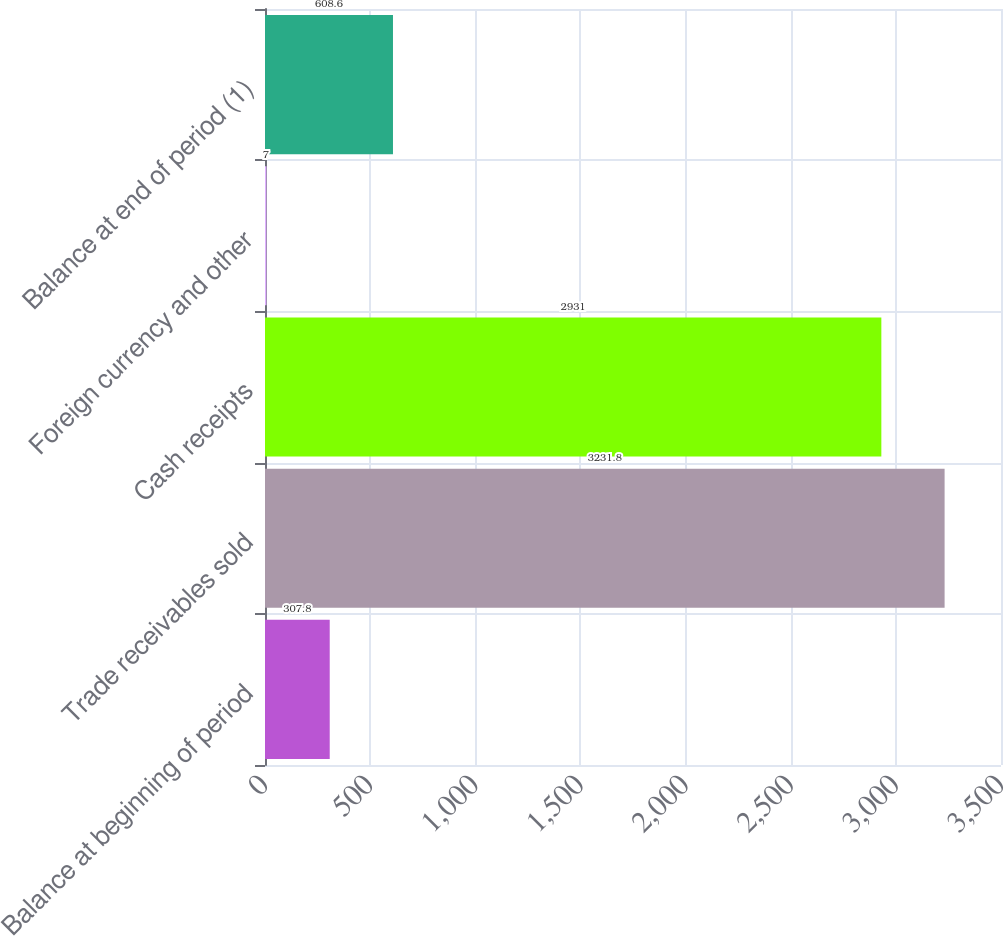<chart> <loc_0><loc_0><loc_500><loc_500><bar_chart><fcel>Balance at beginning of period<fcel>Trade receivables sold<fcel>Cash receipts<fcel>Foreign currency and other<fcel>Balance at end of period (1)<nl><fcel>307.8<fcel>3231.8<fcel>2931<fcel>7<fcel>608.6<nl></chart> 